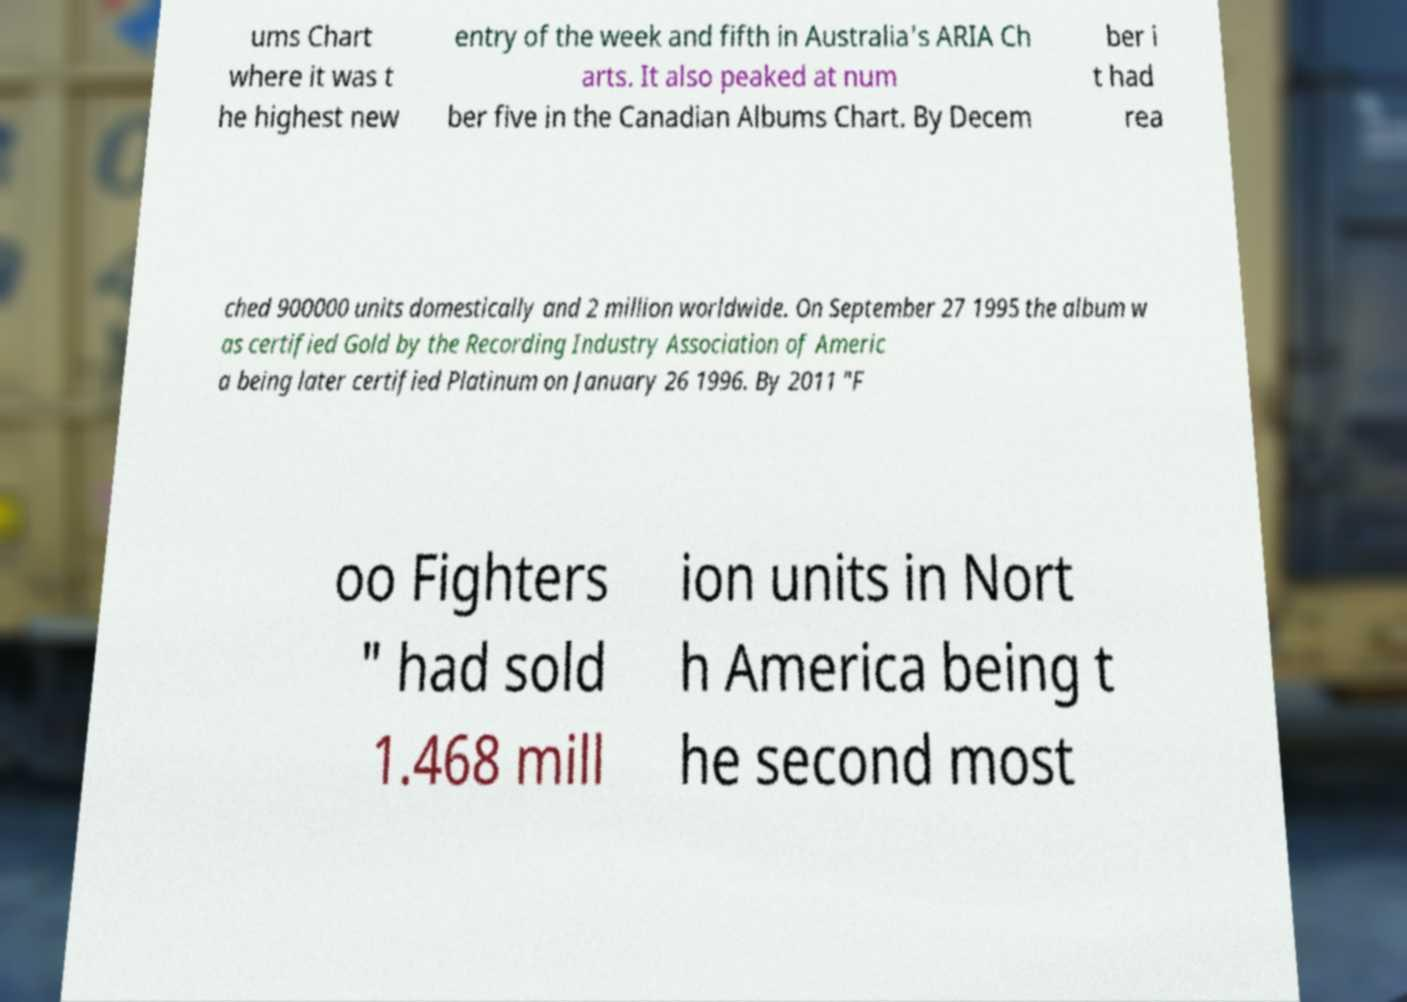Can you accurately transcribe the text from the provided image for me? ums Chart where it was t he highest new entry of the week and fifth in Australia's ARIA Ch arts. It also peaked at num ber five in the Canadian Albums Chart. By Decem ber i t had rea ched 900000 units domestically and 2 million worldwide. On September 27 1995 the album w as certified Gold by the Recording Industry Association of Americ a being later certified Platinum on January 26 1996. By 2011 "F oo Fighters " had sold 1.468 mill ion units in Nort h America being t he second most 